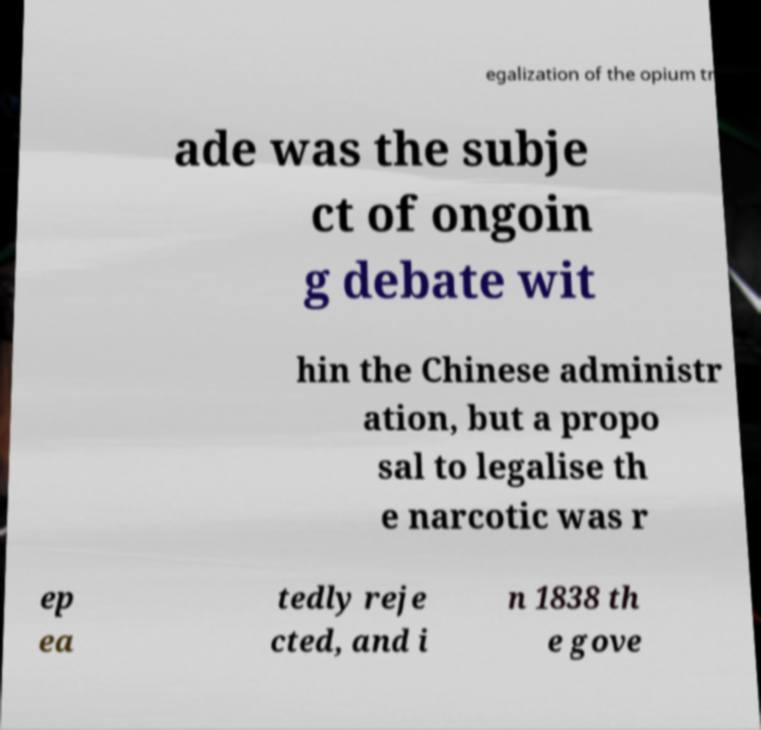Please identify and transcribe the text found in this image. egalization of the opium tr ade was the subje ct of ongoin g debate wit hin the Chinese administr ation, but a propo sal to legalise th e narcotic was r ep ea tedly reje cted, and i n 1838 th e gove 